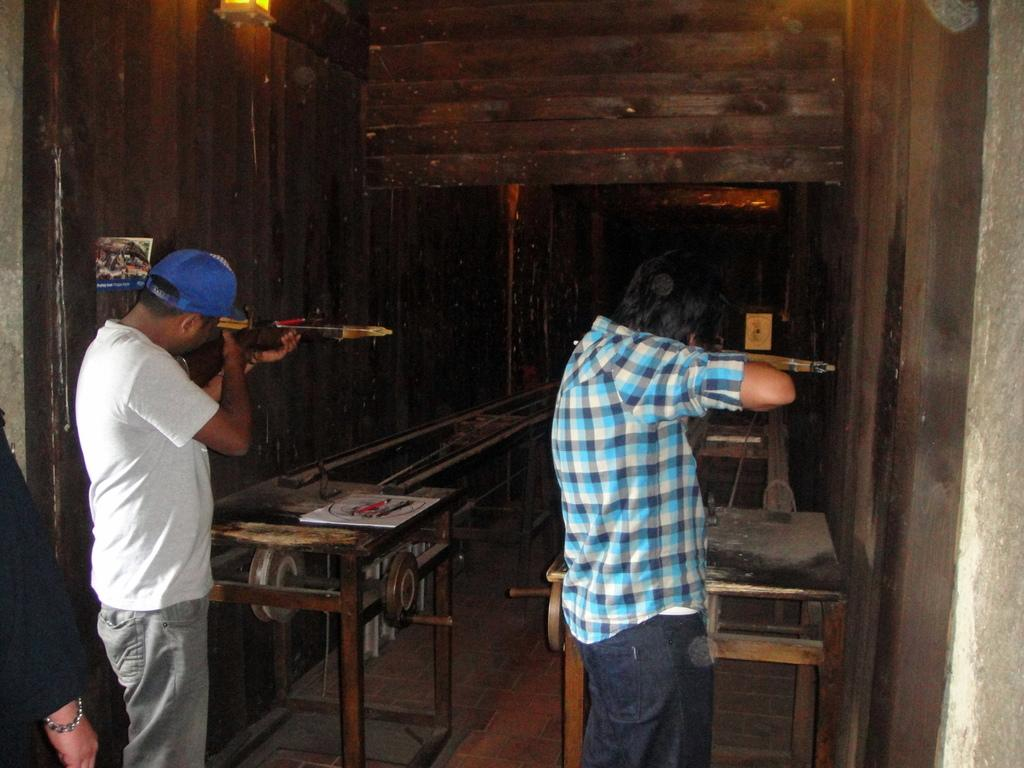How many people are in the image? There are two men in the image. What are the men doing in the image? The men are standing in the image. What are the men holding in their hands? The men are holding objects in their hands. What type of furniture can be seen in the image? There are tables in the image. What type of architectural feature is present in the image? There are walls in the image. Can you tell me how many thumbs are visible in the image? There is no specific mention of thumbs in the image, so it is not possible to determine how many are visible. 